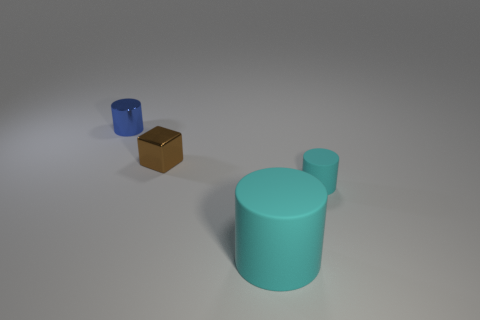Subtract all tiny cylinders. How many cylinders are left? 1 Subtract 1 cylinders. How many cylinders are left? 2 Subtract all blue cylinders. How many cylinders are left? 2 Subtract all cylinders. How many objects are left? 1 Subtract all gray balls. How many cyan cylinders are left? 2 Subtract all tiny cyan cylinders. Subtract all blue metallic balls. How many objects are left? 3 Add 2 cyan cylinders. How many cyan cylinders are left? 4 Add 3 red cubes. How many red cubes exist? 3 Add 4 big blue shiny cylinders. How many objects exist? 8 Subtract 0 gray cubes. How many objects are left? 4 